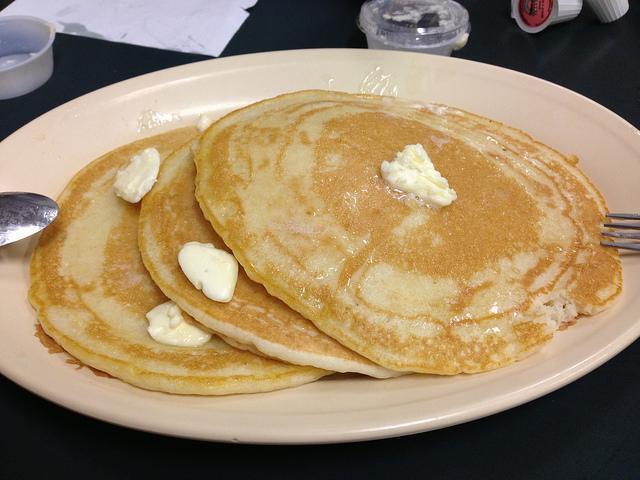How many pancakes are on the plate?
Give a very brief answer. 3. How many different types of doughnuts are there?
Give a very brief answer. 0. 